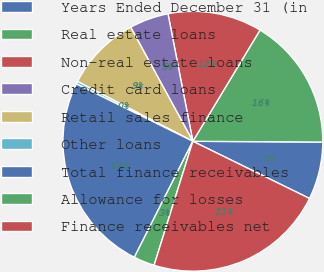Convert chart. <chart><loc_0><loc_0><loc_500><loc_500><pie_chart><fcel>Years Ended December 31 (in<fcel>Real estate loans<fcel>Non-real estate loans<fcel>Credit card loans<fcel>Retail sales finance<fcel>Other loans<fcel>Total finance receivables<fcel>Allowance for losses<fcel>Finance receivables net<nl><fcel>7.16%<fcel>16.45%<fcel>11.72%<fcel>4.88%<fcel>9.44%<fcel>0.33%<fcel>24.85%<fcel>2.61%<fcel>22.57%<nl></chart> 